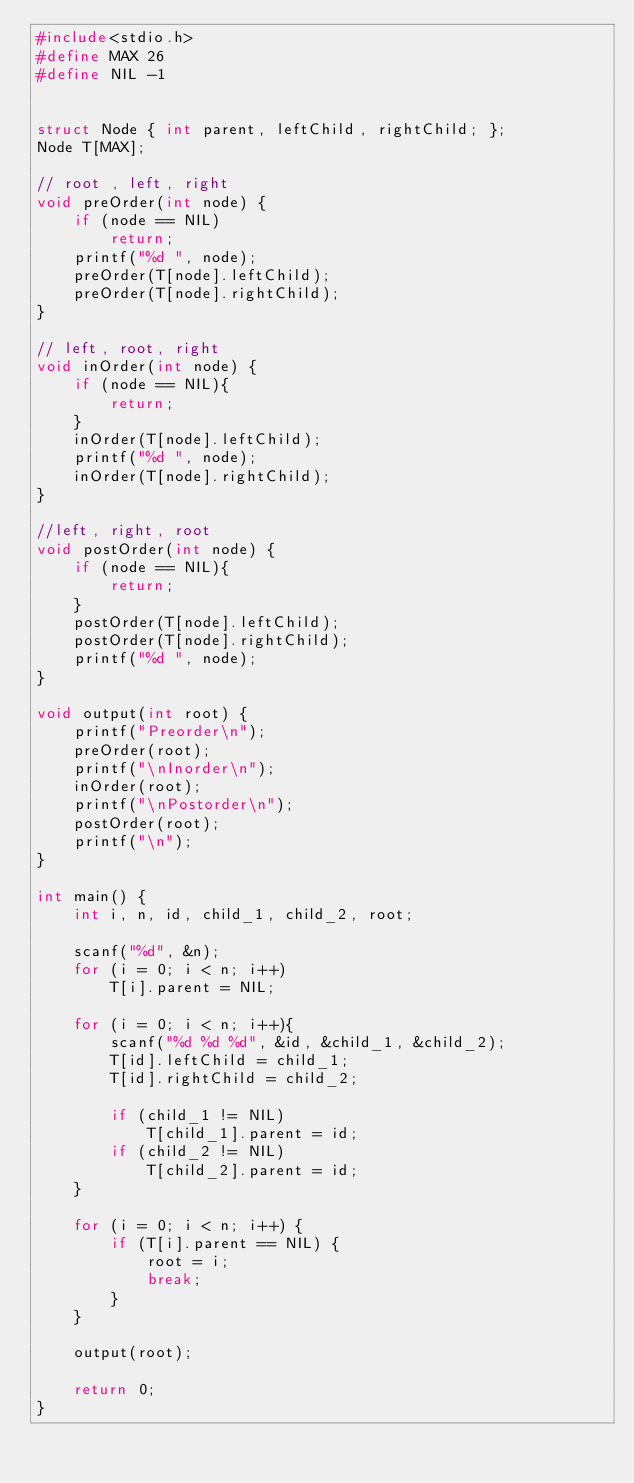<code> <loc_0><loc_0><loc_500><loc_500><_C++_>#include<stdio.h>
#define MAX 26
#define NIL -1


struct Node { int parent, leftChild, rightChild; };
Node T[MAX];

// root , left, right
void preOrder(int node) {
	if (node == NIL)
		return;
	printf("%d ", node);
	preOrder(T[node].leftChild);
	preOrder(T[node].rightChild);
}

// left, root, right
void inOrder(int node) {
	if (node == NIL){
		return;
	}
	inOrder(T[node].leftChild);
	printf("%d ", node);
	inOrder(T[node].rightChild);
}

//left, right, root
void postOrder(int node) {
	if (node == NIL){
		return;
	}
	postOrder(T[node].leftChild);
	postOrder(T[node].rightChild);
	printf("%d ", node);
}

void output(int root) {
	printf("Preorder\n");
	preOrder(root);
	printf("\nInorder\n");
	inOrder(root);
	printf("\nPostorder\n");
	postOrder(root);
	printf("\n");
}

int main() {
	int i, n, id, child_1, child_2, root;

	scanf("%d", &n);
	for (i = 0; i < n; i++)
		T[i].parent = NIL;

	for (i = 0; i < n; i++){
		scanf("%d %d %d", &id, &child_1, &child_2);
		T[id].leftChild = child_1;
		T[id].rightChild = child_2;

		if (child_1 != NIL)
			T[child_1].parent = id;
		if (child_2 != NIL)
			T[child_2].parent = id;
	}

	for (i = 0; i < n; i++) {
		if (T[i].parent == NIL) {
			root = i;
			break;
		}
	}

	output(root);

	return 0;
}</code> 